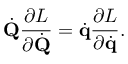<formula> <loc_0><loc_0><loc_500><loc_500>{ \dot { Q } } { \frac { \partial L } { \partial { \dot { Q } } } } = { \dot { q } } { \frac { \partial L } { \partial { \dot { q } } } } .</formula> 